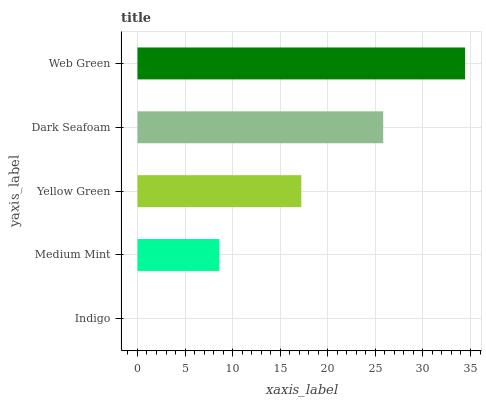Is Indigo the minimum?
Answer yes or no. Yes. Is Web Green the maximum?
Answer yes or no. Yes. Is Medium Mint the minimum?
Answer yes or no. No. Is Medium Mint the maximum?
Answer yes or no. No. Is Medium Mint greater than Indigo?
Answer yes or no. Yes. Is Indigo less than Medium Mint?
Answer yes or no. Yes. Is Indigo greater than Medium Mint?
Answer yes or no. No. Is Medium Mint less than Indigo?
Answer yes or no. No. Is Yellow Green the high median?
Answer yes or no. Yes. Is Yellow Green the low median?
Answer yes or no. Yes. Is Web Green the high median?
Answer yes or no. No. Is Indigo the low median?
Answer yes or no. No. 